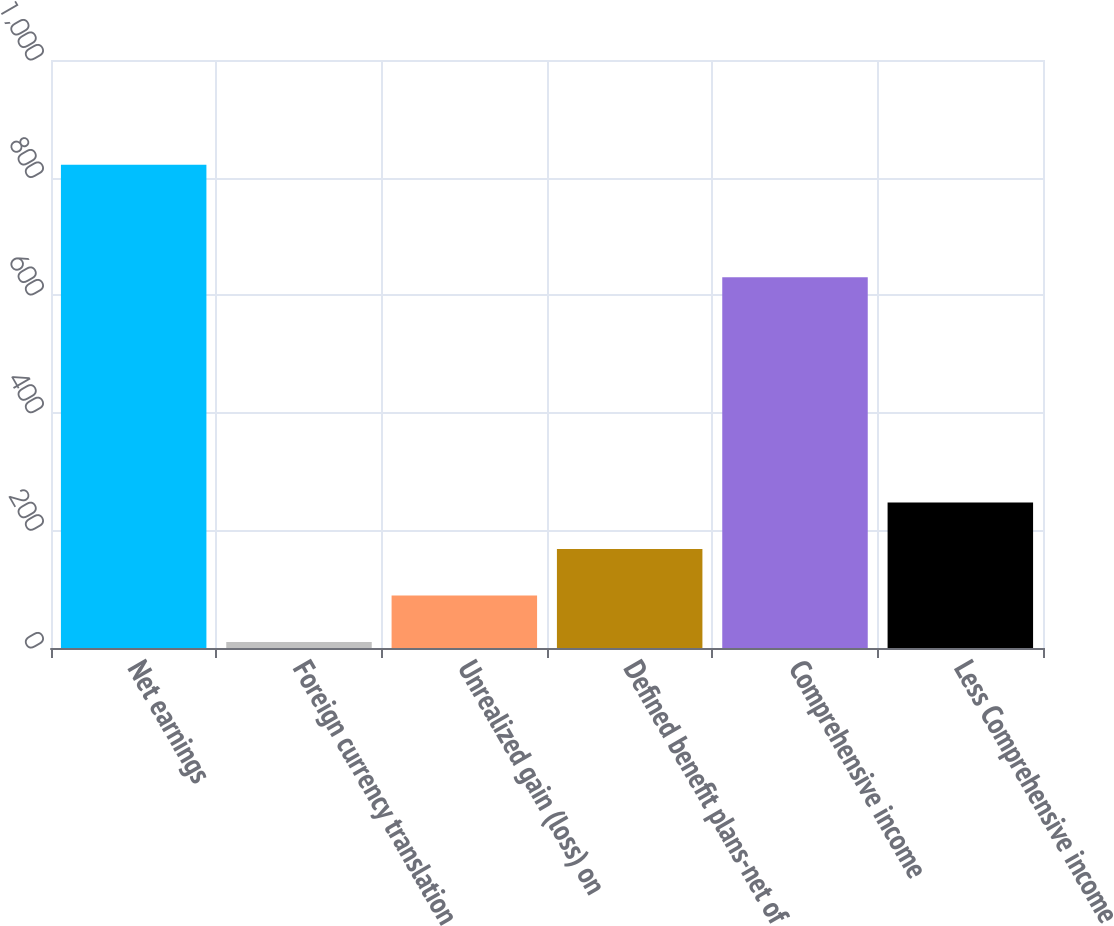Convert chart to OTSL. <chart><loc_0><loc_0><loc_500><loc_500><bar_chart><fcel>Net earnings<fcel>Foreign currency translation<fcel>Unrealized gain (loss) on<fcel>Defined benefit plans-net of<fcel>Comprehensive income<fcel>Less Comprehensive income<nl><fcel>821.94<fcel>10.1<fcel>89.24<fcel>168.38<fcel>630.6<fcel>247.52<nl></chart> 